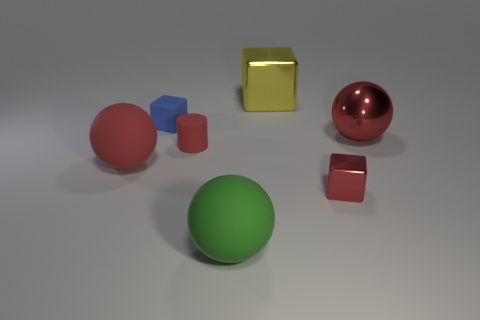Add 2 balls. How many objects exist? 9 Subtract all cubes. How many objects are left? 4 Subtract all small red spheres. Subtract all yellow metal objects. How many objects are left? 6 Add 6 small blocks. How many small blocks are left? 8 Add 7 big yellow cubes. How many big yellow cubes exist? 8 Subtract 1 red spheres. How many objects are left? 6 